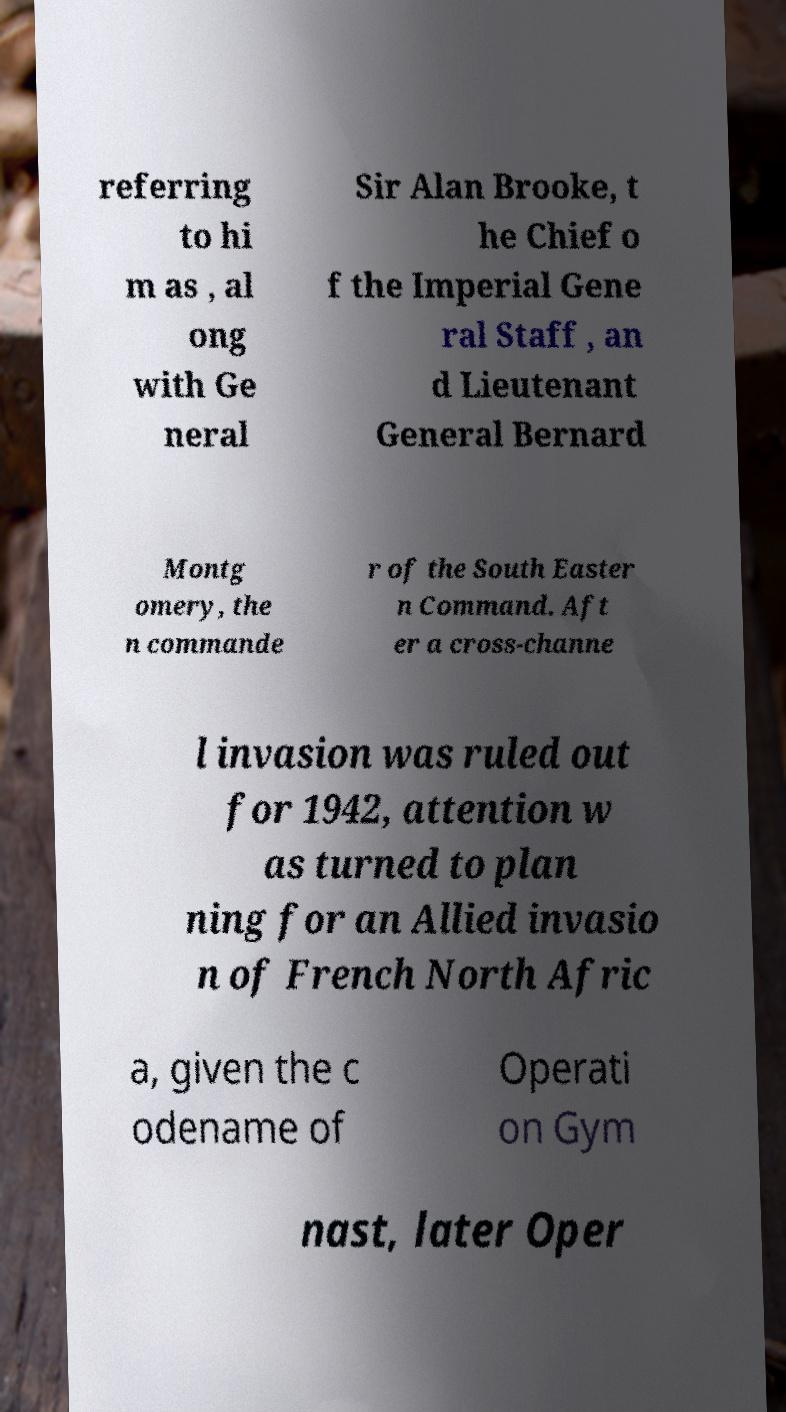Could you extract and type out the text from this image? referring to hi m as , al ong with Ge neral Sir Alan Brooke, t he Chief o f the Imperial Gene ral Staff , an d Lieutenant General Bernard Montg omery, the n commande r of the South Easter n Command. Aft er a cross-channe l invasion was ruled out for 1942, attention w as turned to plan ning for an Allied invasio n of French North Afric a, given the c odename of Operati on Gym nast, later Oper 